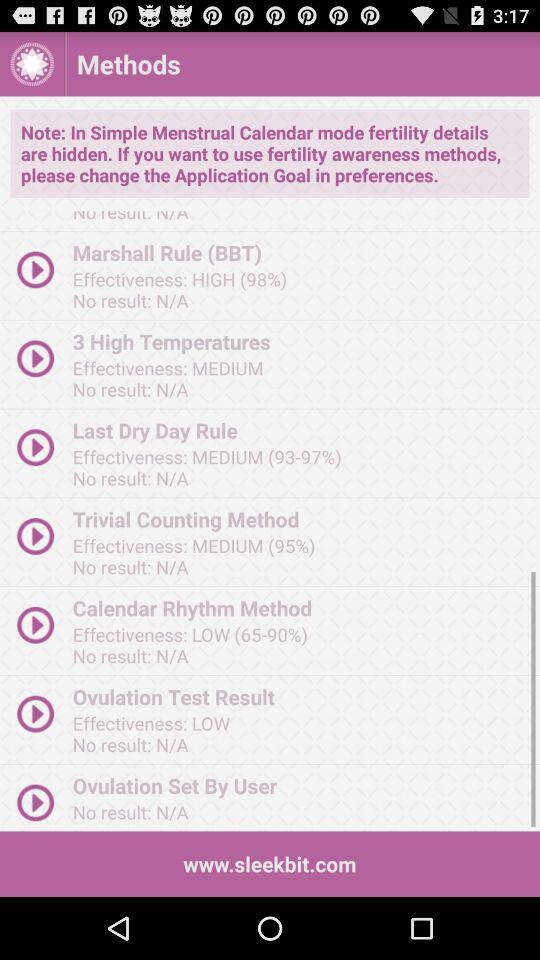What is the effectiveness percentage of the "Last Dry Day Rule"? The effectiveness percentage of the "Last Dry Day Rule" ranges from 93 to 97. 